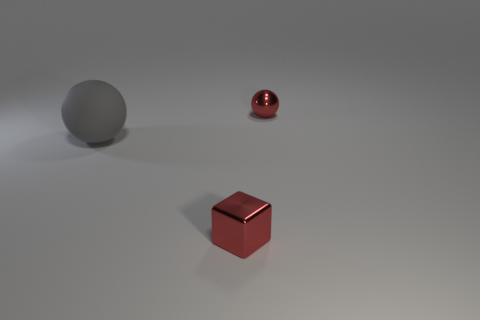Can you describe the texture and material of the objects shown? Certainly! The objects in the image appear to have different textures and materials. The large sphere in the background has a matte finish and is likely made of a rubber-like material due to its lack of shine and smoother surface. The small cube and the small sphere at the forefront have a glossy finish, indicative of a metallic material, and they both reflect light, which further suggests they are made of metal. 